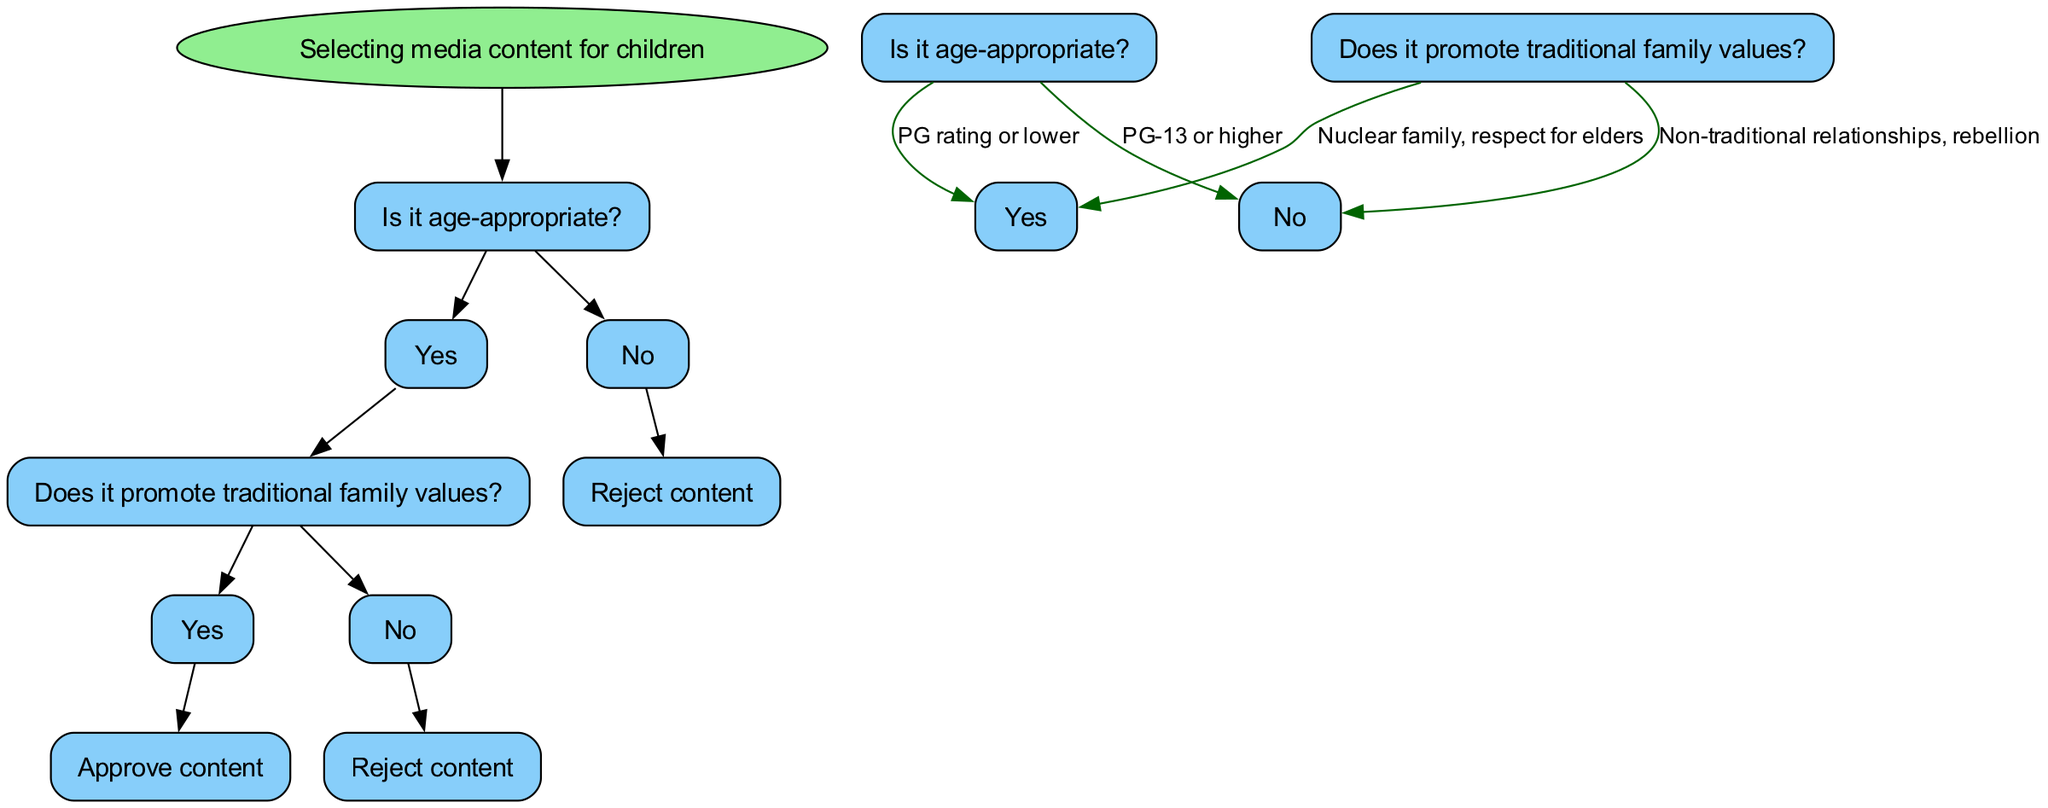What is the root node of the diagram? The root node is "Selecting media content for children," which is the starting point of the decision tree illustrating the evaluation process for children's media.
Answer: Selecting media content for children How many children nodes does the root node have? The root node has one child node, which is "Is it age-appropriate?" leading to further evaluation of content.
Answer: 1 What is the label on the edge leading from "Is it age-appropriate?" to "Yes"? The label on the edge indicates "PG rating or lower," specifying the criteria for the content being considered age-appropriate.
Answer: PG rating or lower If content is age-appropriate but does not promote traditional family values, what is the outcome? The outcome would be to "Reject content," as indicated in the decision tree if the content fails to support conservative family principles.
Answer: Reject content What is the relationship between "Does it promote traditional family values?" and its two potential outcomes? The relationship is a decision point with two options: "Yes," leading to "Approve content," and "No," leading to "Reject content," both determining the acceptance of the media based on family values.
Answer: Approve content and Reject content What happens if the content is not age-appropriate? If the content is not age-appropriate, the decision tree immediately leads to "Reject content," indicating no further evaluation occurs at this point.
Answer: Reject content How many total nodes are in the decision tree? There are five total nodes within the decision tree, including the root, the age-appropriate check, the values check, and the two final decisions on content approval or rejection.
Answer: 5 What value is associated with the edge labeled "Non-traditional relationships, rebellion"? The label "Non-traditional relationships, rebellion" signifies the rejection of content that contradicts traditional family values during the evaluation process.
Answer: Non-traditional relationships, rebellion What type of content does the tree favor when it leads to "Approve content"? The tree favors content that promotes traditional family values such as a nuclear family and respect for elders, as indicated in the pathway leading to approval.
Answer: Traditional family values 